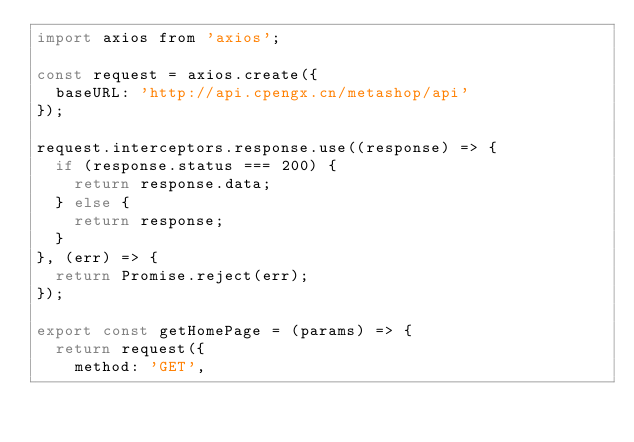Convert code to text. <code><loc_0><loc_0><loc_500><loc_500><_JavaScript_>import axios from 'axios';

const request = axios.create({
  baseURL: 'http://api.cpengx.cn/metashop/api'
});

request.interceptors.response.use((response) => {
  if (response.status === 200) {
    return response.data;
  } else {
    return response;
  }
}, (err) => {
  return Promise.reject(err);
});

export const getHomePage = (params) => {
  return request({
    method: 'GET',</code> 